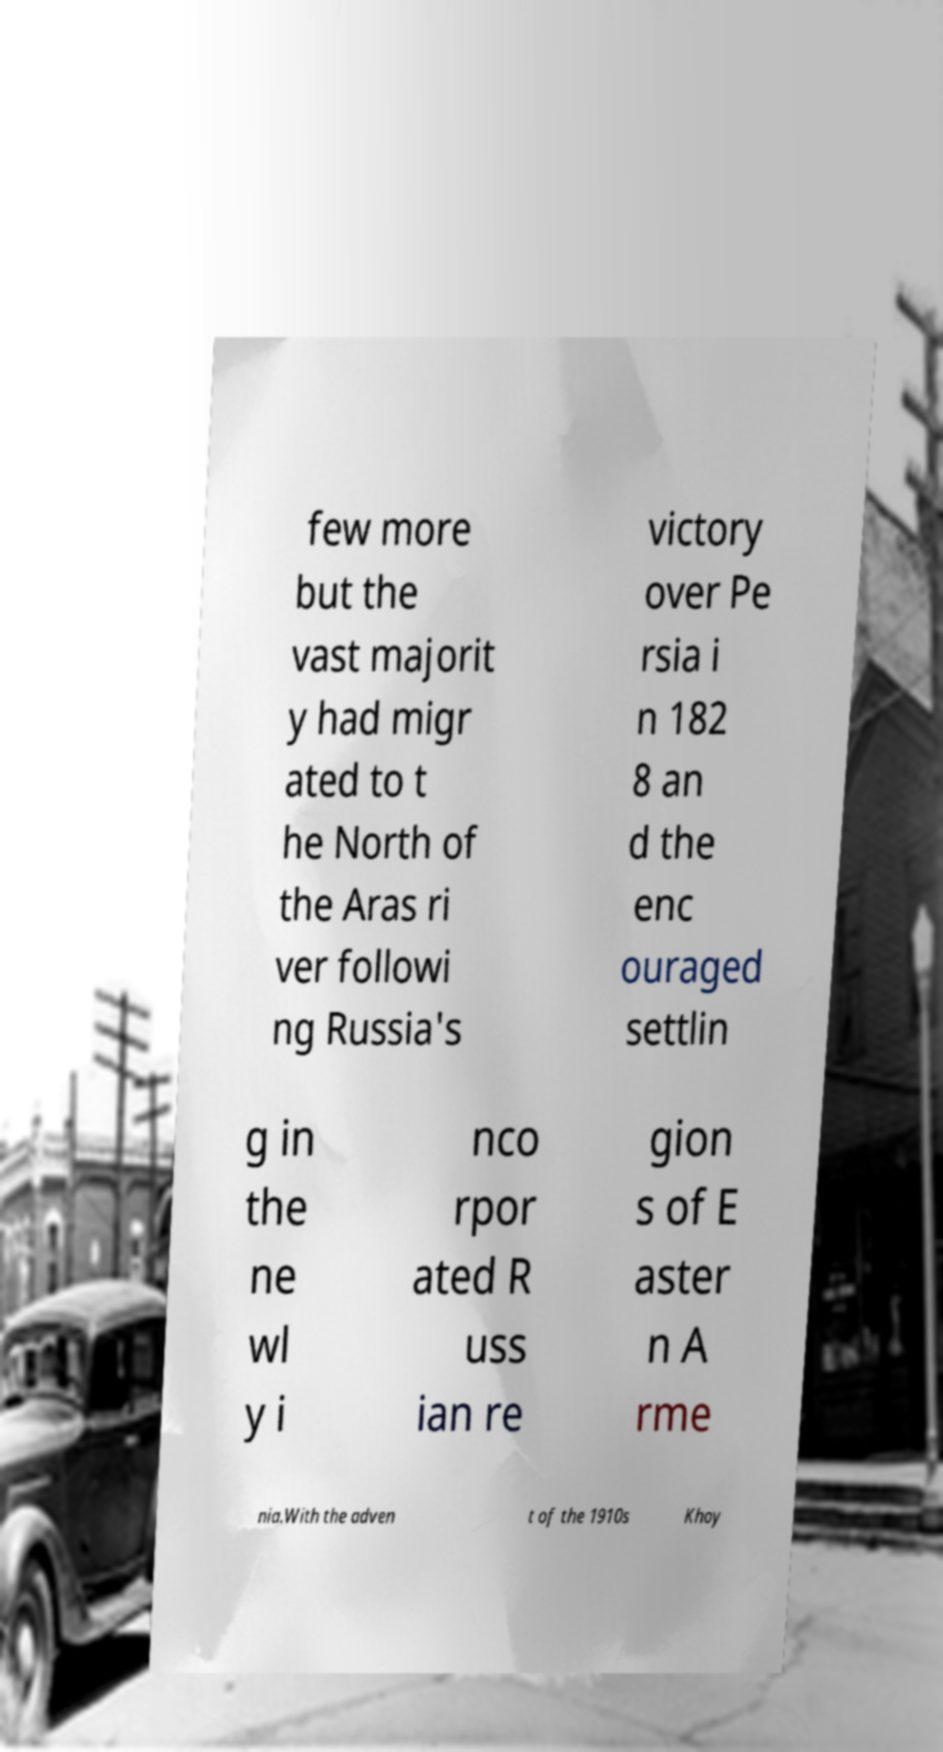I need the written content from this picture converted into text. Can you do that? few more but the vast majorit y had migr ated to t he North of the Aras ri ver followi ng Russia's victory over Pe rsia i n 182 8 an d the enc ouraged settlin g in the ne wl y i nco rpor ated R uss ian re gion s of E aster n A rme nia.With the adven t of the 1910s Khoy 